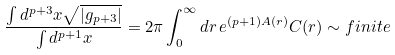Convert formula to latex. <formula><loc_0><loc_0><loc_500><loc_500>\frac { \int d ^ { p + 3 } x \sqrt { | g _ { p + 3 } | } } { \int d ^ { p + 1 } x } = 2 \pi \int _ { 0 } ^ { \infty } d r \, e ^ { ( p + 1 ) A ( r ) } C ( r ) \sim f i n i t e</formula> 